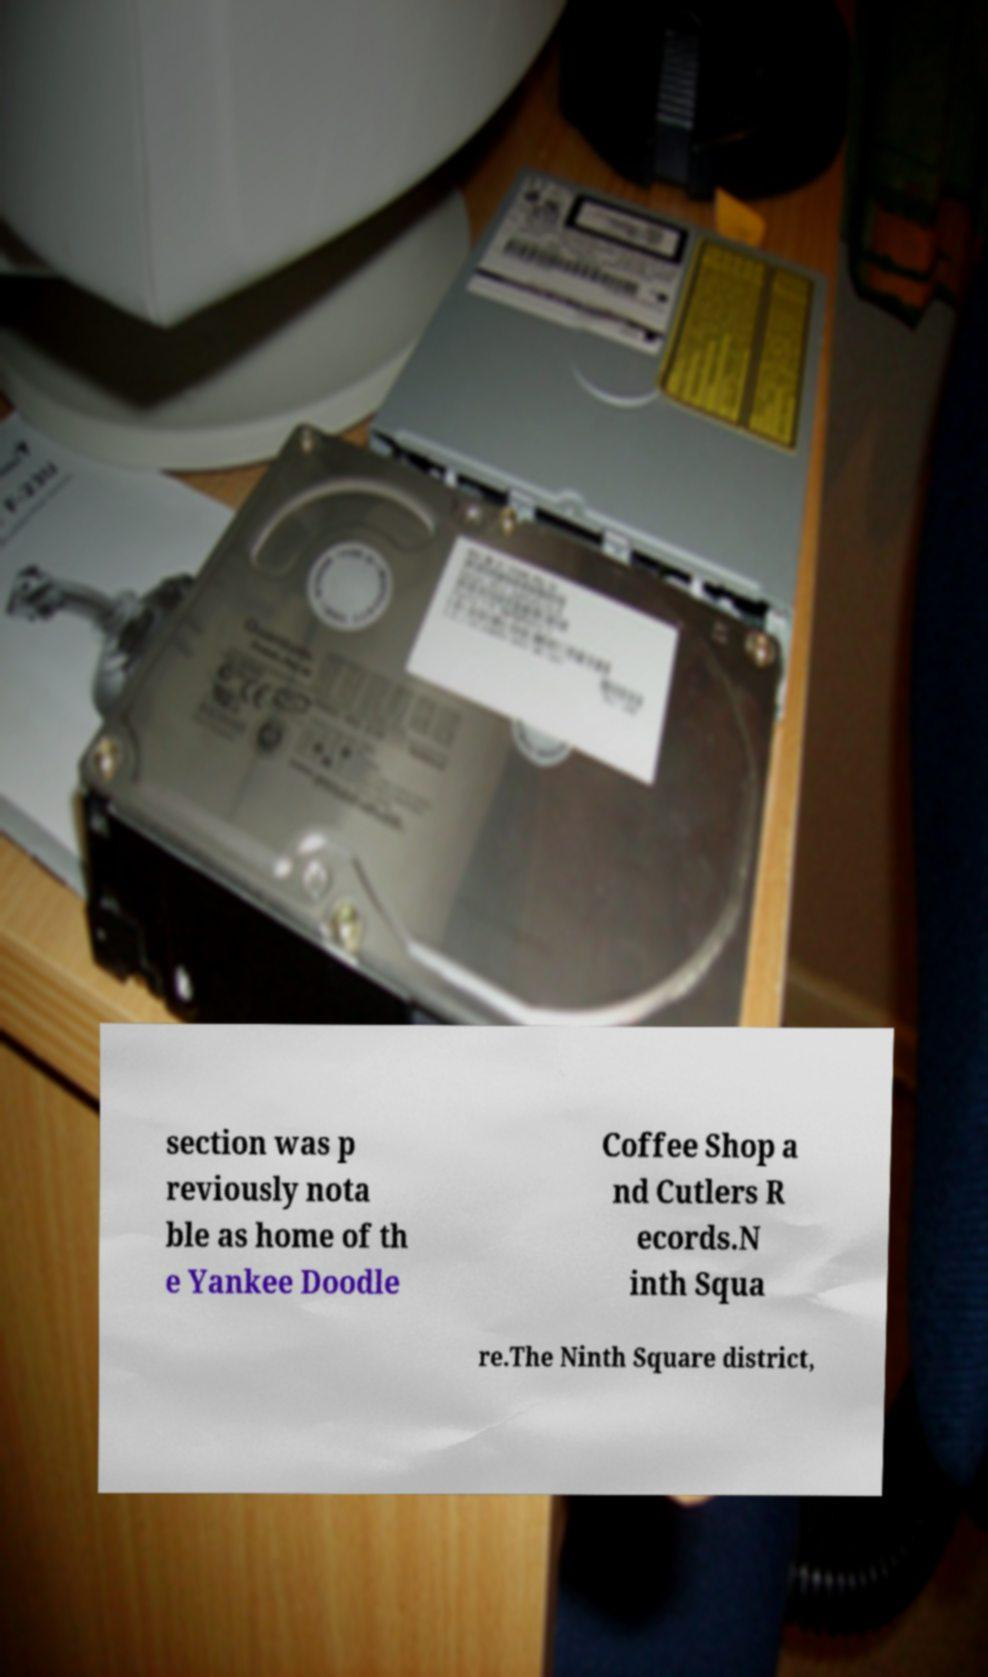I need the written content from this picture converted into text. Can you do that? section was p reviously nota ble as home of th e Yankee Doodle Coffee Shop a nd Cutlers R ecords.N inth Squa re.The Ninth Square district, 